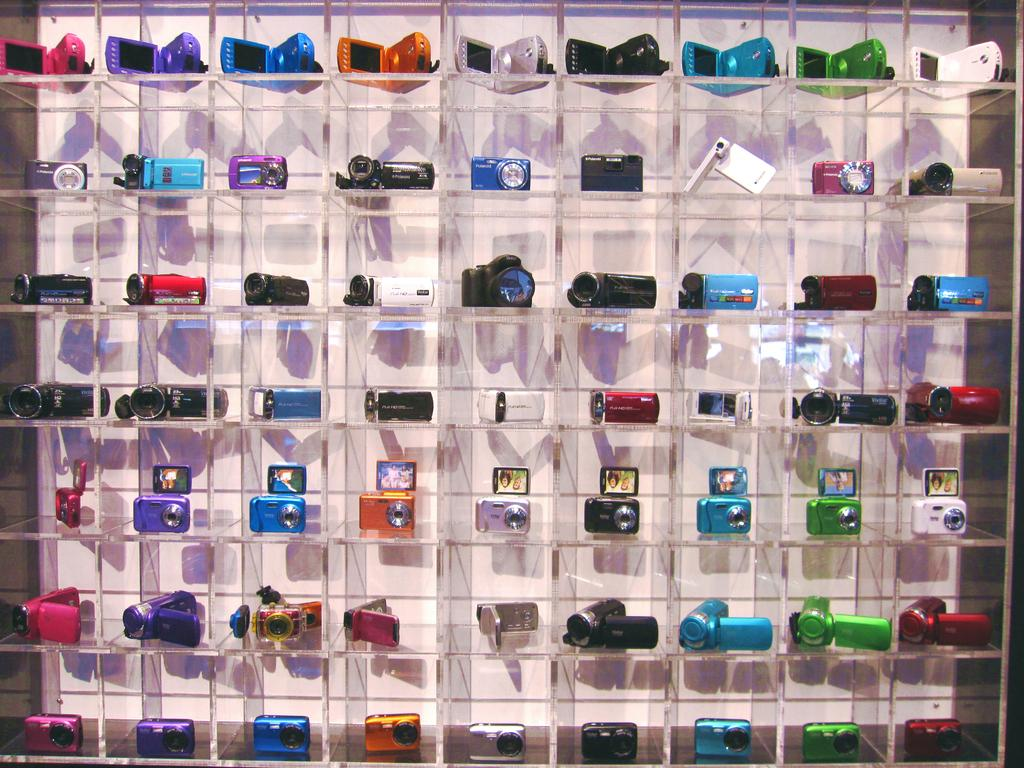What objects are present in the image? There are cameras in the image. How are the cameras arranged in the image? The cameras are arranged in a rack. What type of ear is visible on the cameras in the image? There are no ears present on the cameras in the image, as cameras do not have ears. 